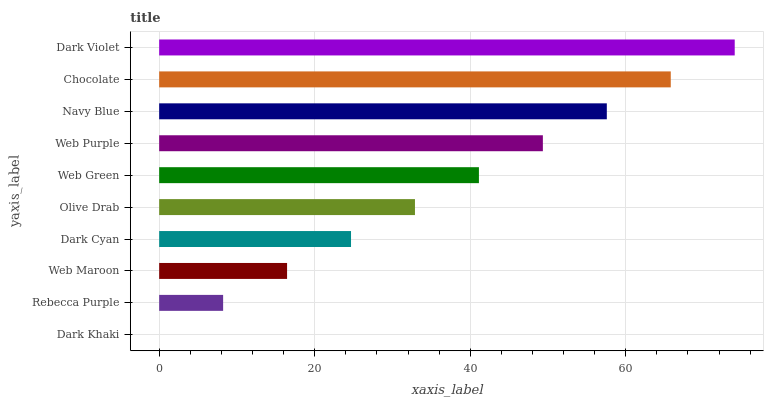Is Dark Khaki the minimum?
Answer yes or no. Yes. Is Dark Violet the maximum?
Answer yes or no. Yes. Is Rebecca Purple the minimum?
Answer yes or no. No. Is Rebecca Purple the maximum?
Answer yes or no. No. Is Rebecca Purple greater than Dark Khaki?
Answer yes or no. Yes. Is Dark Khaki less than Rebecca Purple?
Answer yes or no. Yes. Is Dark Khaki greater than Rebecca Purple?
Answer yes or no. No. Is Rebecca Purple less than Dark Khaki?
Answer yes or no. No. Is Web Green the high median?
Answer yes or no. Yes. Is Olive Drab the low median?
Answer yes or no. Yes. Is Navy Blue the high median?
Answer yes or no. No. Is Dark Cyan the low median?
Answer yes or no. No. 